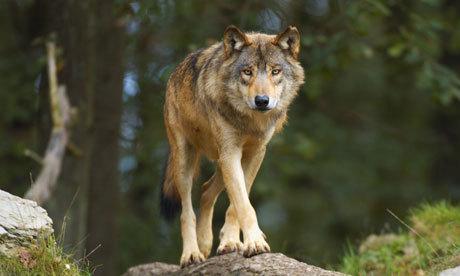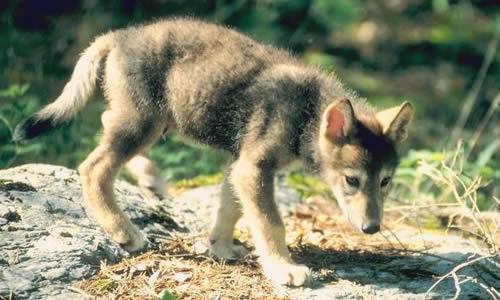The first image is the image on the left, the second image is the image on the right. Analyze the images presented: Is the assertion "One image contains exactly three wolves posed in a row with their bodies angled forward." valid? Answer yes or no. No. The first image is the image on the left, the second image is the image on the right. Examine the images to the left and right. Is the description "There are only two wolves." accurate? Answer yes or no. Yes. 